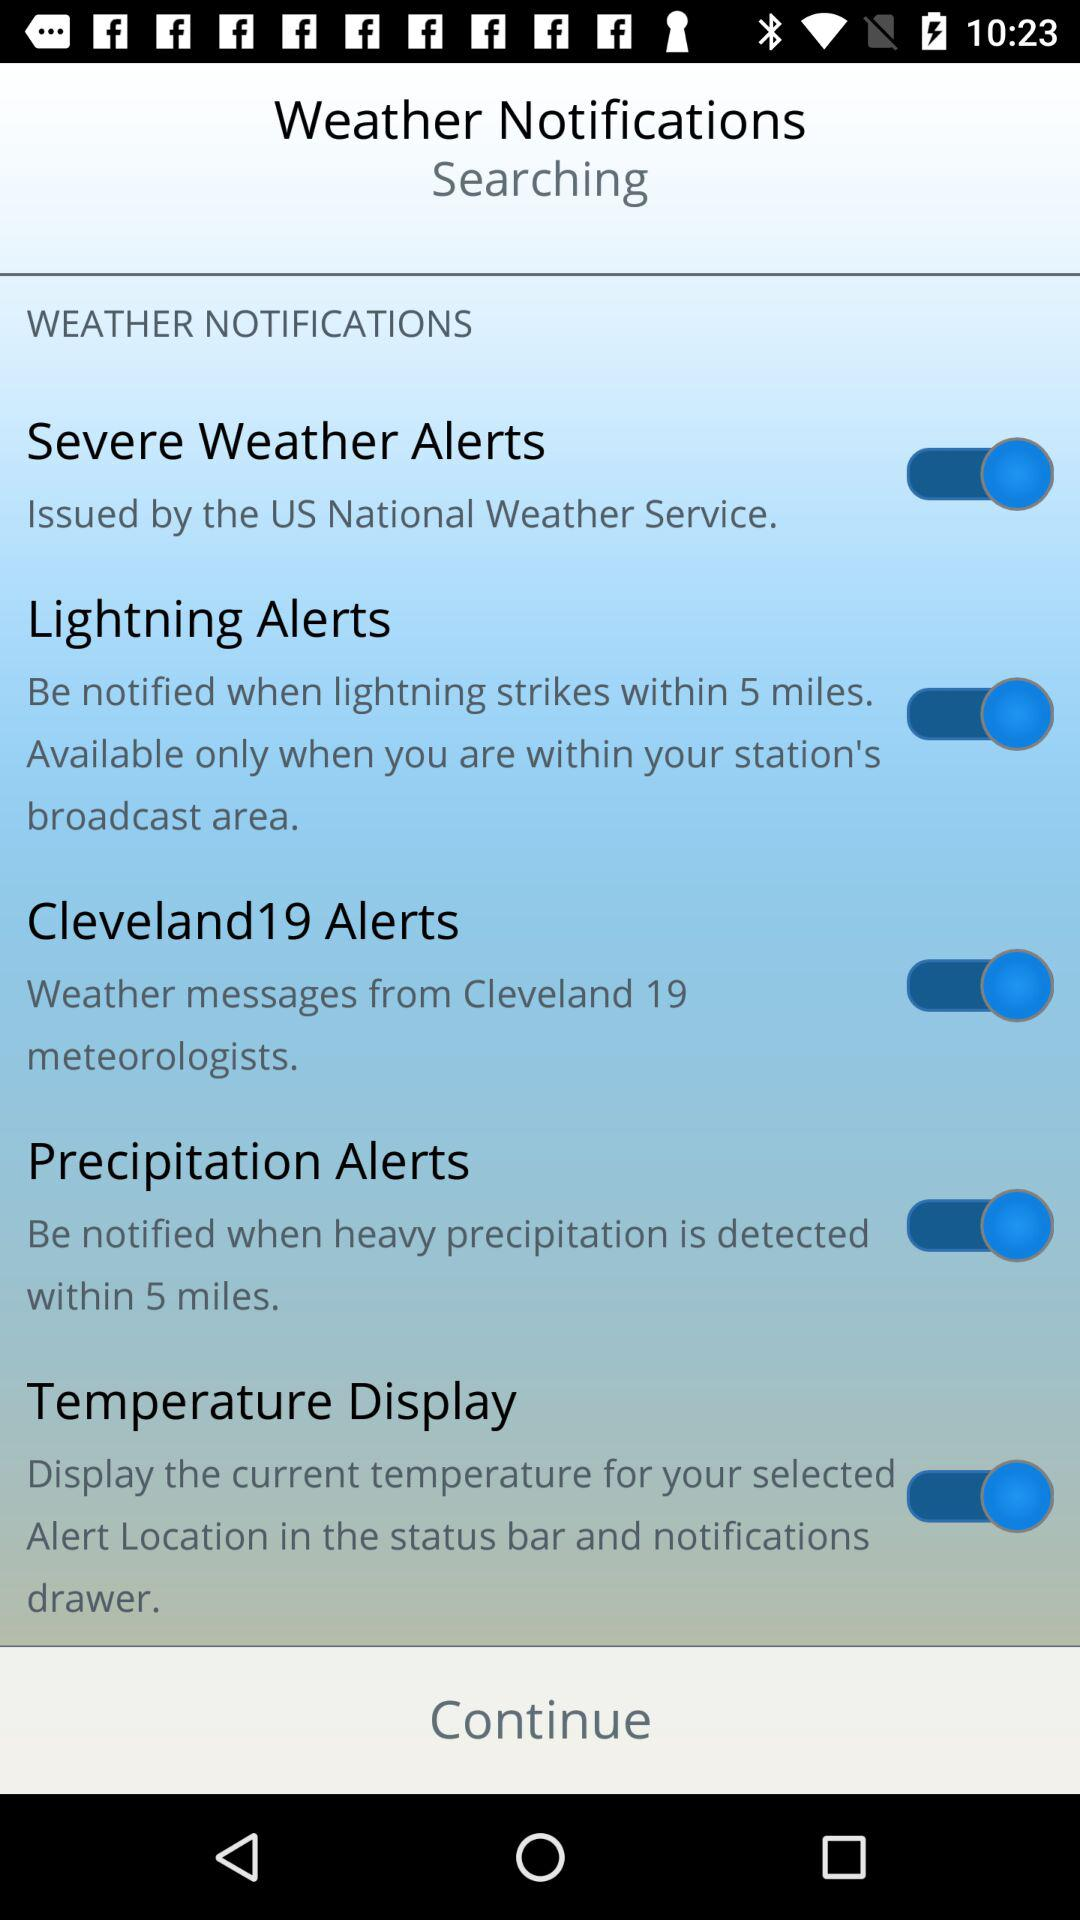What is the status of "Lightning Alerts"? The status is "on". 